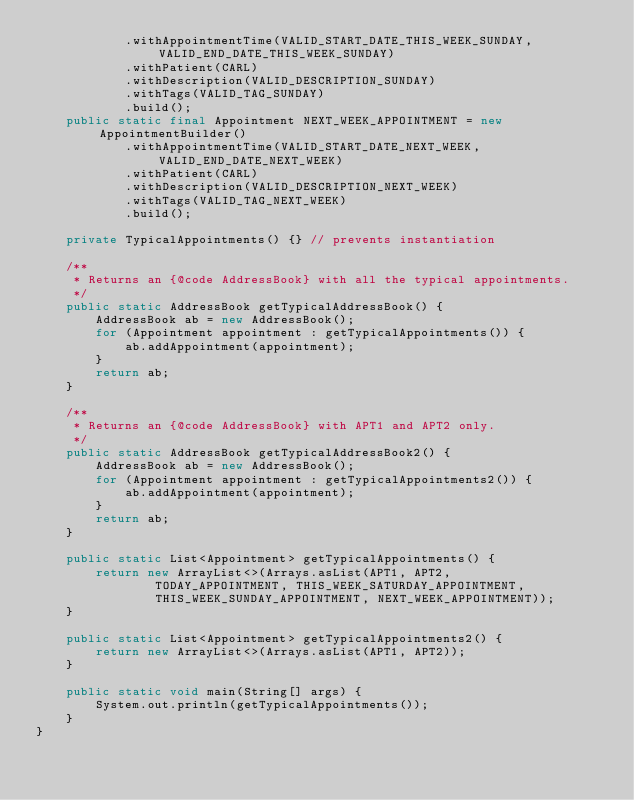<code> <loc_0><loc_0><loc_500><loc_500><_Java_>            .withAppointmentTime(VALID_START_DATE_THIS_WEEK_SUNDAY, VALID_END_DATE_THIS_WEEK_SUNDAY)
            .withPatient(CARL)
            .withDescription(VALID_DESCRIPTION_SUNDAY)
            .withTags(VALID_TAG_SUNDAY)
            .build();
    public static final Appointment NEXT_WEEK_APPOINTMENT = new AppointmentBuilder()
            .withAppointmentTime(VALID_START_DATE_NEXT_WEEK, VALID_END_DATE_NEXT_WEEK)
            .withPatient(CARL)
            .withDescription(VALID_DESCRIPTION_NEXT_WEEK)
            .withTags(VALID_TAG_NEXT_WEEK)
            .build();

    private TypicalAppointments() {} // prevents instantiation

    /**
     * Returns an {@code AddressBook} with all the typical appointments.
     */
    public static AddressBook getTypicalAddressBook() {
        AddressBook ab = new AddressBook();
        for (Appointment appointment : getTypicalAppointments()) {
            ab.addAppointment(appointment);
        }
        return ab;
    }

    /**
     * Returns an {@code AddressBook} with APT1 and APT2 only.
     */
    public static AddressBook getTypicalAddressBook2() {
        AddressBook ab = new AddressBook();
        for (Appointment appointment : getTypicalAppointments2()) {
            ab.addAppointment(appointment);
        }
        return ab;
    }

    public static List<Appointment> getTypicalAppointments() {
        return new ArrayList<>(Arrays.asList(APT1, APT2,
                TODAY_APPOINTMENT, THIS_WEEK_SATURDAY_APPOINTMENT,
                THIS_WEEK_SUNDAY_APPOINTMENT, NEXT_WEEK_APPOINTMENT));
    }

    public static List<Appointment> getTypicalAppointments2() {
        return new ArrayList<>(Arrays.asList(APT1, APT2));
    }

    public static void main(String[] args) {
        System.out.println(getTypicalAppointments());
    }
}
</code> 